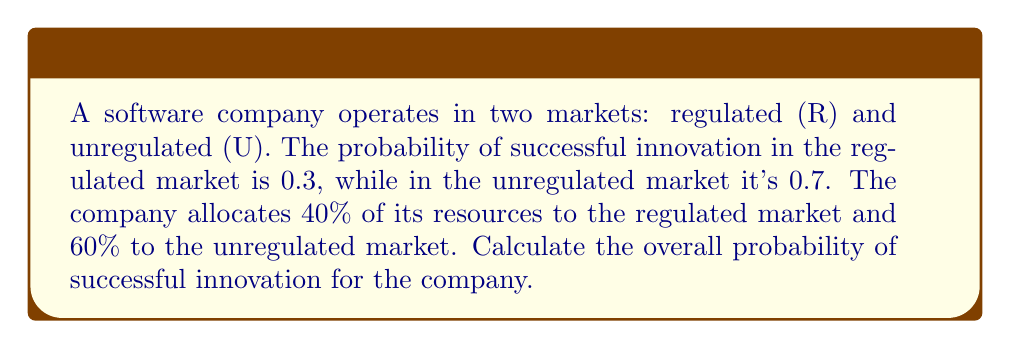Solve this math problem. To solve this problem, we'll use the law of total probability. Let's break it down step by step:

1) Let S be the event of successful innovation. We need to find P(S).

2) We have two mutually exclusive and exhaustive events:
   R: The innovation attempt is in the regulated market
   U: The innovation attempt is in the unregulated market

3) Given:
   P(R) = 0.4 (40% resources allocated to regulated market)
   P(U) = 0.6 (60% resources allocated to unregulated market)
   P(S|R) = 0.3 (probability of success in regulated market)
   P(S|U) = 0.7 (probability of success in unregulated market)

4) By the law of total probability:
   $$P(S) = P(S|R) \cdot P(R) + P(S|U) \cdot P(U)$$

5) Substituting the values:
   $$P(S) = 0.3 \cdot 0.4 + 0.7 \cdot 0.6$$

6) Calculating:
   $$P(S) = 0.12 + 0.42 = 0.54$$

Therefore, the overall probability of successful innovation for the company is 0.54 or 54%.
Answer: 0.54 